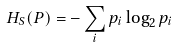<formula> <loc_0><loc_0><loc_500><loc_500>H _ { S } ( P ) = - \sum _ { i } p _ { i } \log _ { 2 } p _ { i }</formula> 